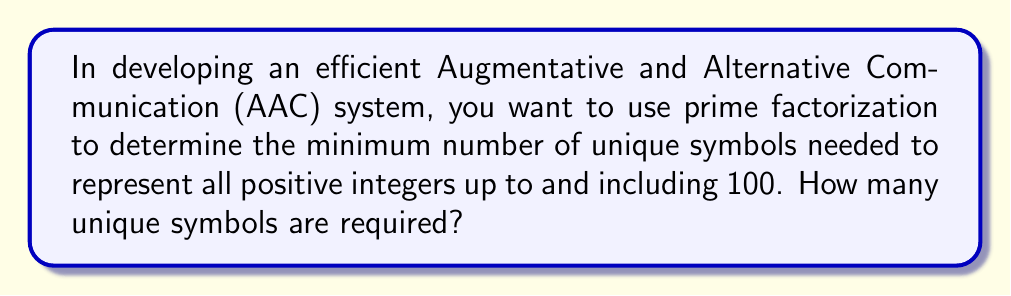Could you help me with this problem? Let's approach this step-by-step:

1) First, we need to find the prime factorization of 100:
   $100 = 2^2 \times 5^2$

2) This means that any number from 1 to 100 can be represented as:
   $2^a \times 5^b$, where $0 \leq a \leq 2$ and $0 \leq b \leq 2$

3) For the exponent of 2, we need 3 symbols (for 0, 1, and 2)
   For the exponent of 5, we also need 3 symbols (for 0, 1, and 2)

4) We also need symbols for the prime numbers themselves (2 and 5)

5) Additionally, we need a symbol to represent multiplication

6) Therefore, the total number of unique symbols needed is:
   3 (for 2's exponent) + 3 (for 5's exponent) + 2 (for primes 2 and 5) + 1 (for multiplication) = 9

This system allows us to represent any number from 1 to 100 efficiently. For example:
- 1 would be represented as $2^0 \times 5^0$
- 100 would be represented as $2^2 \times 5^2$
- 37 would be represented as $2^2 \times 5^1 \times 2^0 \times 5^0 \times 2^1$

This prime factorization method provides an efficient way to represent numbers in an AAC system, potentially reducing the cognitive load for users.
Answer: 9 symbols 